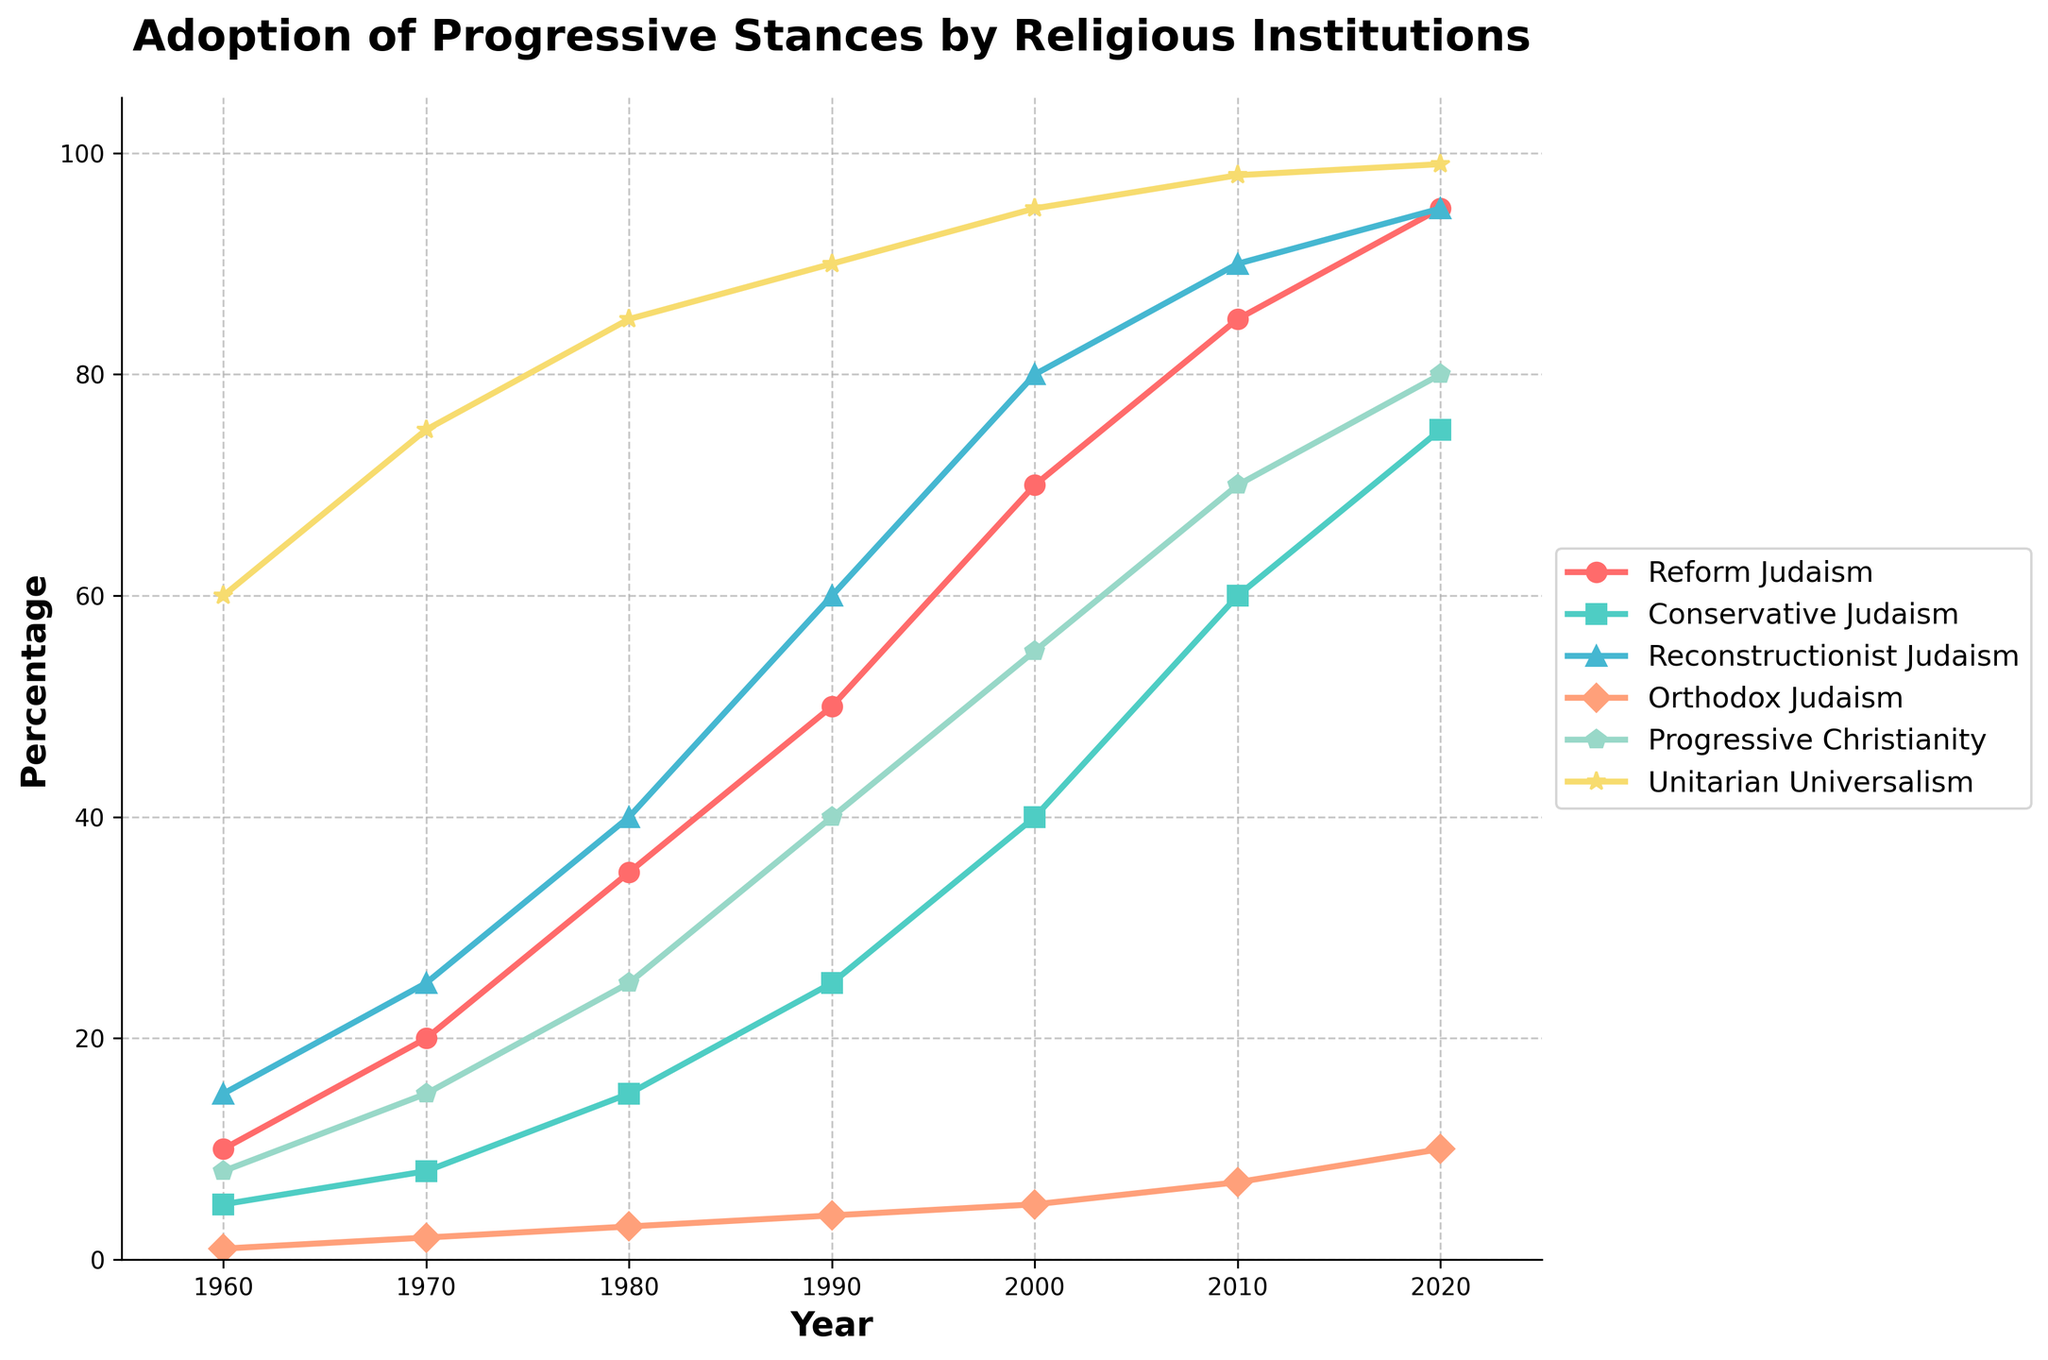In what year did Reform Judaism first reach 70% adoption of progressive stances? By looking at the line representing Reform Judaism, we see that it reaches 70% in the year 2000.
Answer: 2000 Which religious institution had the highest adoption percentage in 2020? By observing the lines at the endpoint in 2020, Unitarian Universalism reaches the highest percentage at 99%.
Answer: Unitarian Universalism How has the percentage adoption by Conservative Judaism changed from 1990 to 2010? Subtract the 1990 percentage (25%) from the 2010 percentage (60%). The change is 60% - 25% = 35%.
Answer: 35% In which decade did all shown religious institutions first surpass a 20% adoption rate? By looking at each line, the 1980s was the first decade where every institution surpassed the 20% threshold.
Answer: 1980s Comparatively, how much more progressive was Progressive Christianity in 2010 vs Orthodox Judaism? In 2010, Progressive Christianity is at 70%, while Orthodox Judaism is at 7%. The difference is 70% - 7% = 63%.
Answer: 63% What is the overall trend observed across all religious institutions from 1960 to 2020? All lines show a generally increasing trend over the years from 1960 to 2020, indicating that all religious institutions gradually adopt more progressive stances over time.
Answer: Increasing trend At what point does the Reconstructionist Judaism line surpass the Progressive Christianity line? By observing the graph, we see that Reconstructionist Judaism never surpasses Progressive Christianity from 1960 to 2020.
Answer: Never Which institution shows the steadiest increase in adoption over the years? By assessing the smoothness and linearity of the lines, Unitarian Universalism shows the steadiest increase, with fewer fluctuations than the others.
Answer: Unitarian Universalism What is the average percentage of adoption for Orthodox Judaism between 1960 and 2020? Summing up the percentages for Orthodox Judaism (1, 2, 3, 4, 5, 7, 10) and dividing by the number of data points (7) gives the average: (1+2+3+4+5+7+10)/7 ≈ 4.57.
Answer: Approximately 4.57 